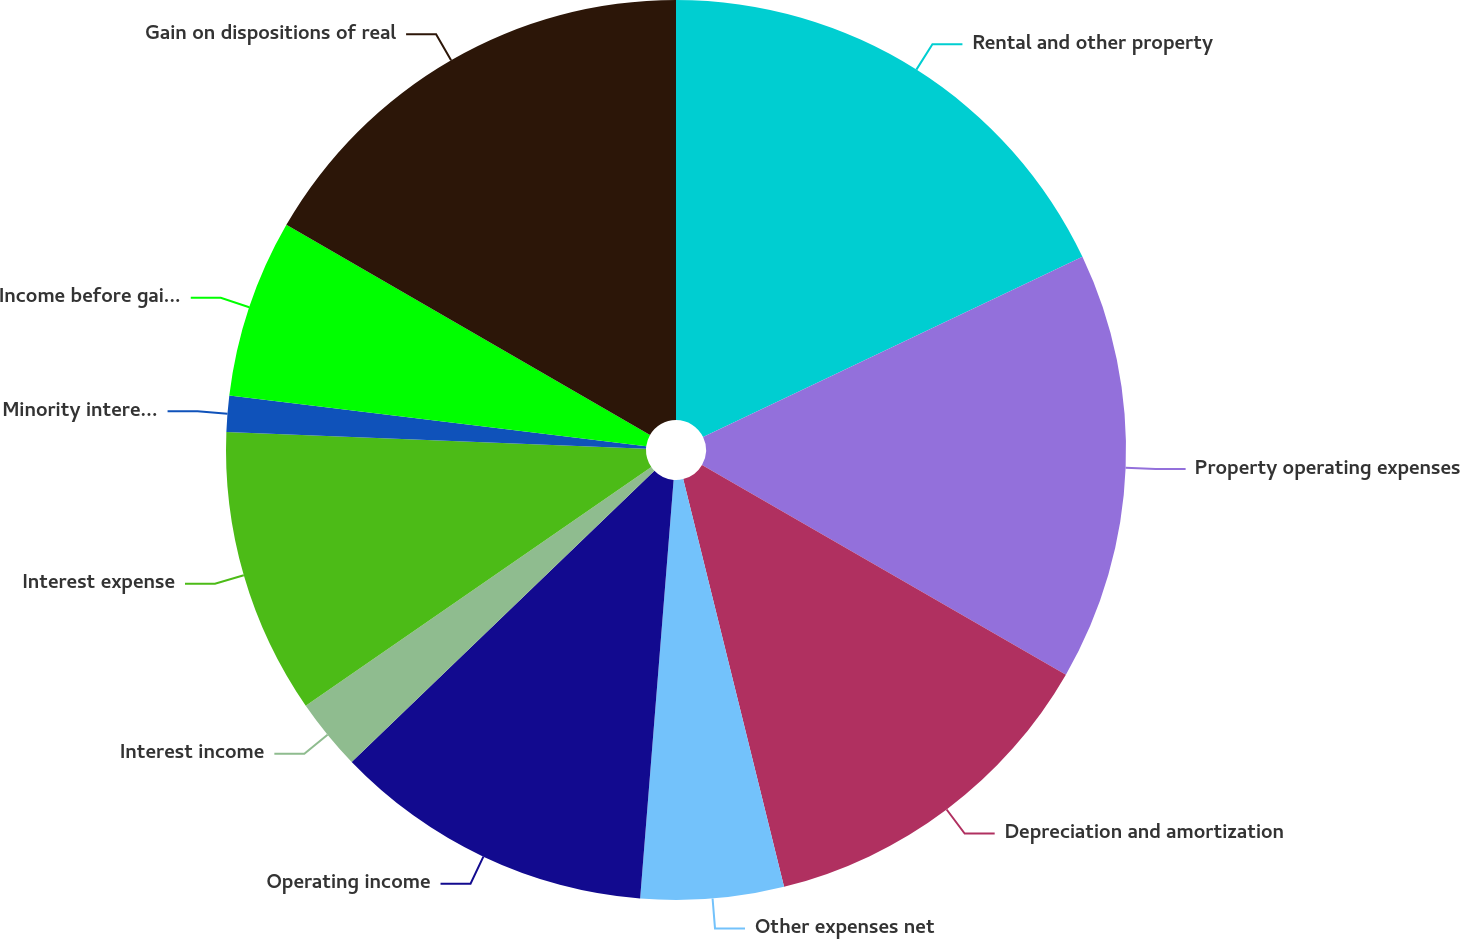Convert chart. <chart><loc_0><loc_0><loc_500><loc_500><pie_chart><fcel>Rental and other property<fcel>Property operating expenses<fcel>Depreciation and amortization<fcel>Other expenses net<fcel>Operating income<fcel>Interest income<fcel>Interest expense<fcel>Minority interest in<fcel>Income before gain on<fcel>Gain on dispositions of real<nl><fcel>17.94%<fcel>15.38%<fcel>12.82%<fcel>5.13%<fcel>11.54%<fcel>2.57%<fcel>10.26%<fcel>1.29%<fcel>6.41%<fcel>16.66%<nl></chart> 